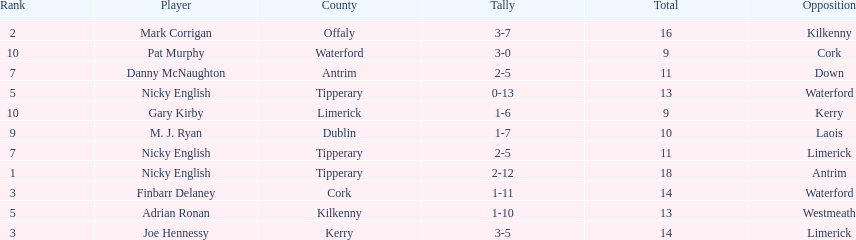How many people are on the list? 9. 